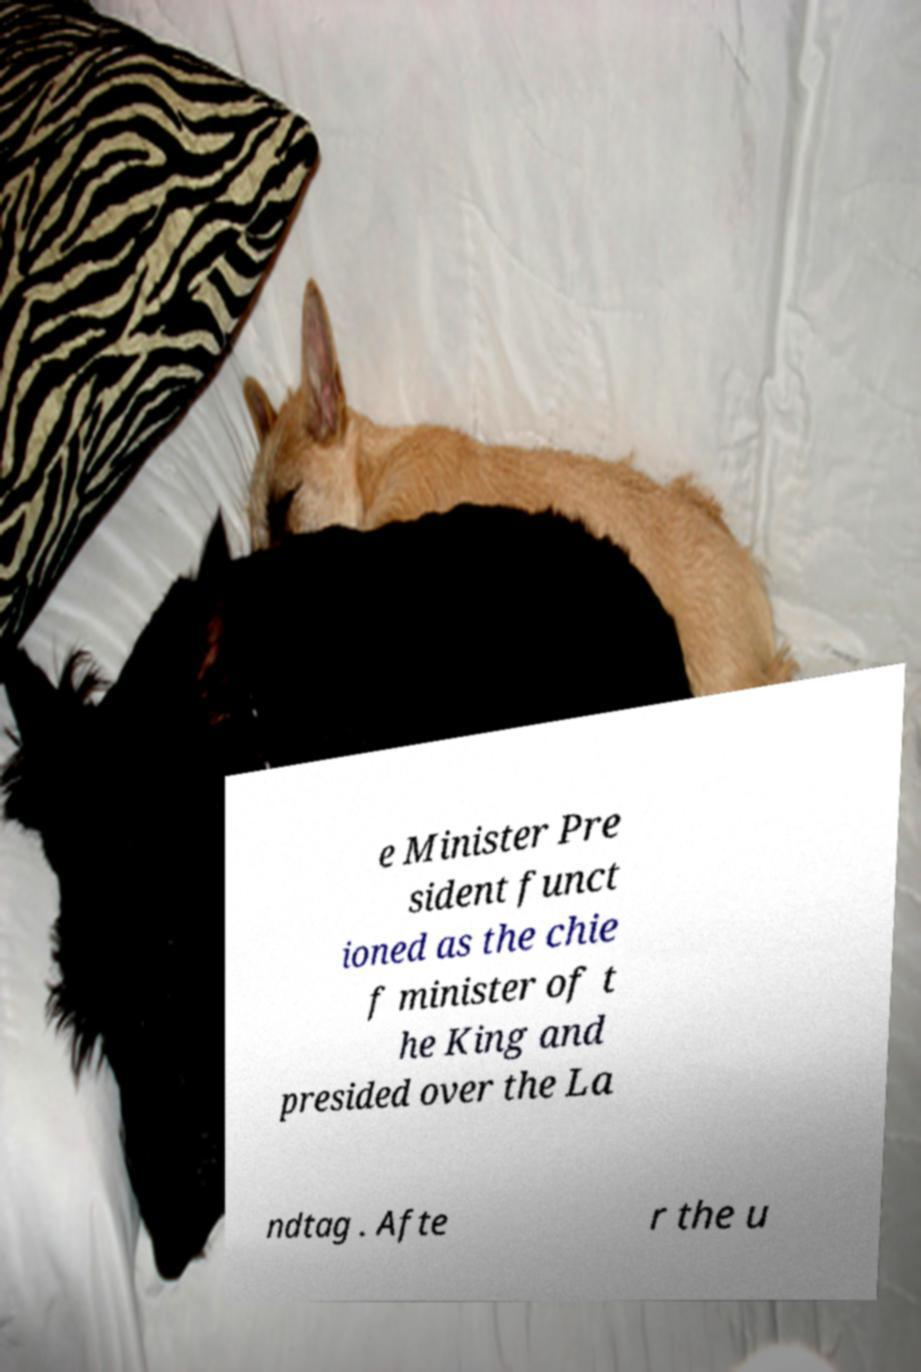Can you accurately transcribe the text from the provided image for me? e Minister Pre sident funct ioned as the chie f minister of t he King and presided over the La ndtag . Afte r the u 